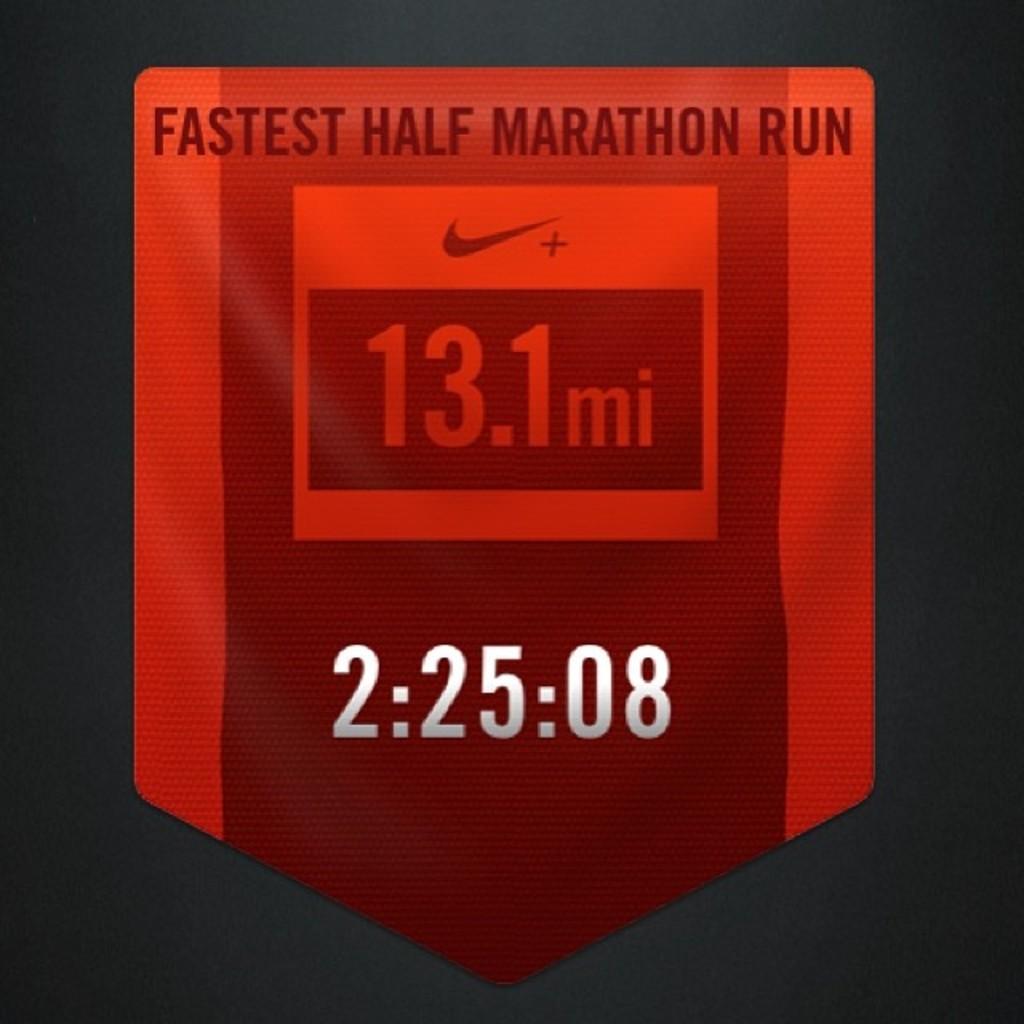What is the distance shown on this banner?
Keep it short and to the point. 13.1. 